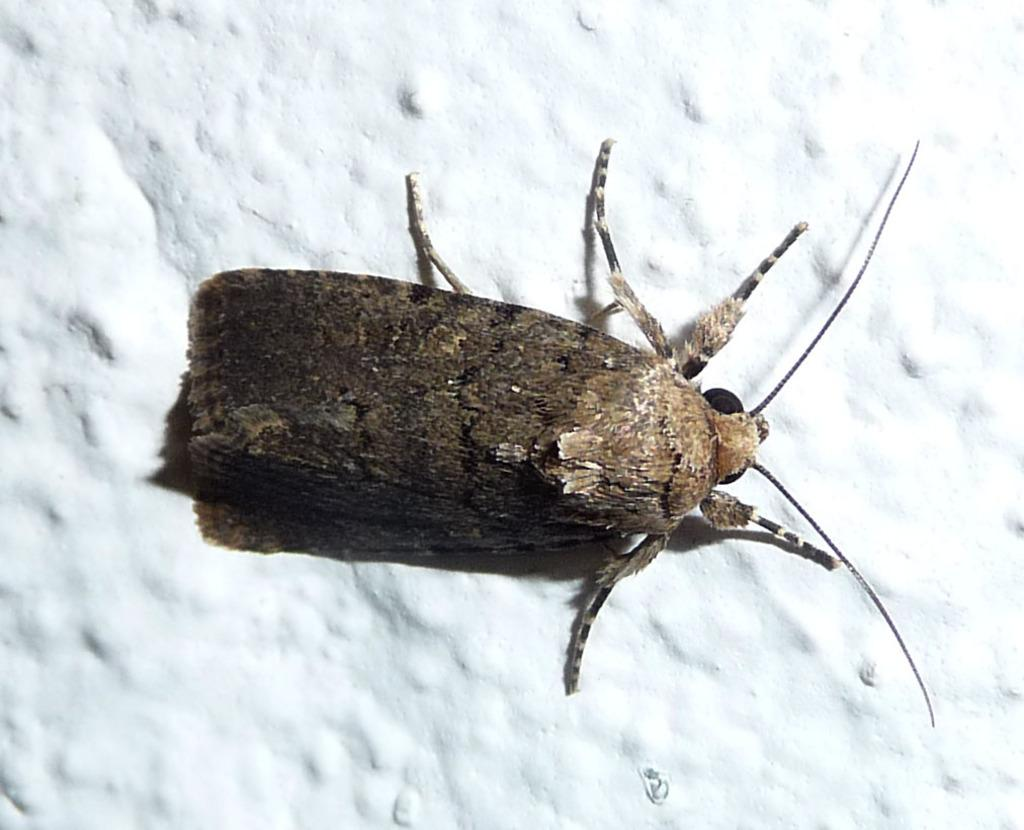What type of creature is in the picture? There is an insect in the picture. What are the main features of the insect? The insect has wings, a body, legs, and a head. What is the background of the image? There is a white surface in the backdrop of the image. What type of battle is taking place between the insect and the texture in the image? There is no battle or texture present in the image; it features an insect with specific features against a white background. 